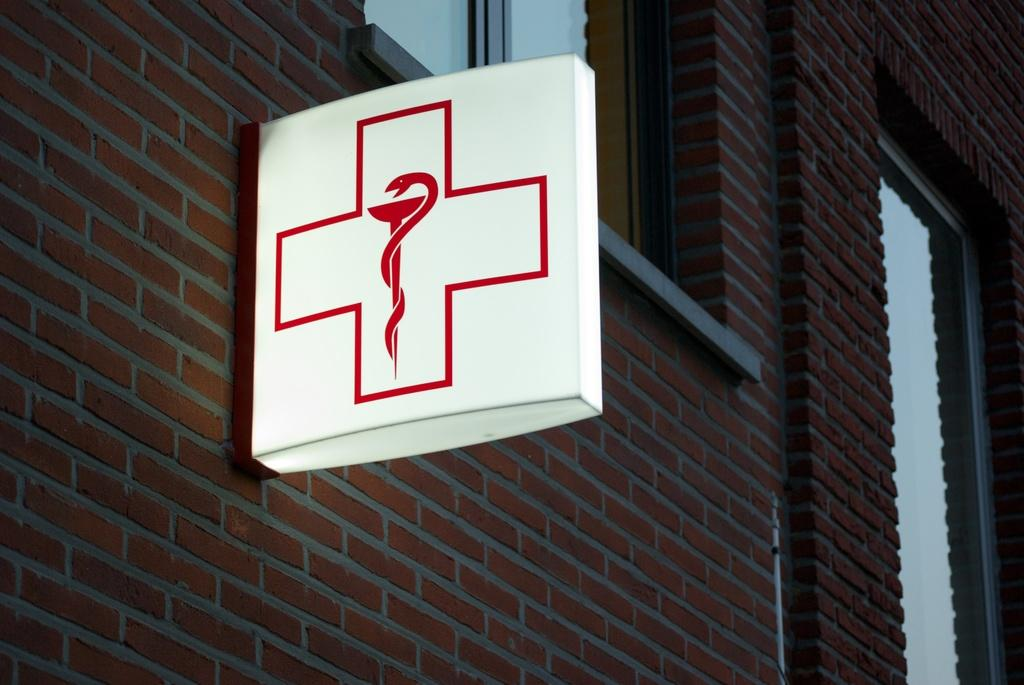What type of structure is visible in the image? There is a building in the image. Can you describe the color of the building? The building is brown and ash in color. What material is the building made of? The building is made up of bricks. Are there any specific features of the building's windows? Yes, there are glass windows in the building. What is attached to the building and its color? There is a white-colored board attached to the building. What type of cake is being served in the building in the image? There is no cake present in the image; it only features a building with a white-colored board attached to it. 